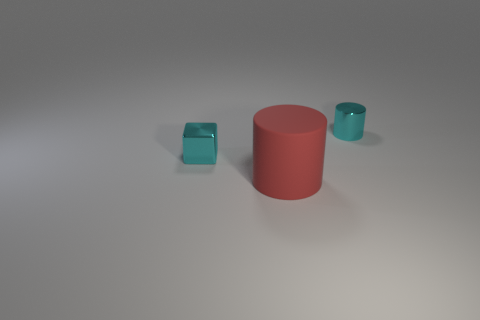Is the color of the metallic block the same as the small metallic cylinder?
Make the answer very short. Yes. Are there any other things that are the same shape as the matte thing?
Provide a short and direct response. Yes. Is the color of the object behind the small shiny block the same as the block?
Give a very brief answer. Yes. There is a small cylinder that is the same material as the cube; what color is it?
Provide a succinct answer. Cyan. What number of cylinders are either large matte objects or small cyan metallic objects?
Keep it short and to the point. 2. What number of things are either small cyan metallic cylinders or tiny cyan things to the right of the rubber cylinder?
Keep it short and to the point. 1. Are there any tiny metallic blocks?
Keep it short and to the point. Yes. What number of tiny cubes have the same color as the small cylinder?
Provide a succinct answer. 1. What is the material of the cube that is the same color as the tiny cylinder?
Give a very brief answer. Metal. There is a cylinder that is behind the big red object that is on the left side of the tiny cyan cylinder; what is its size?
Your answer should be very brief. Small. 